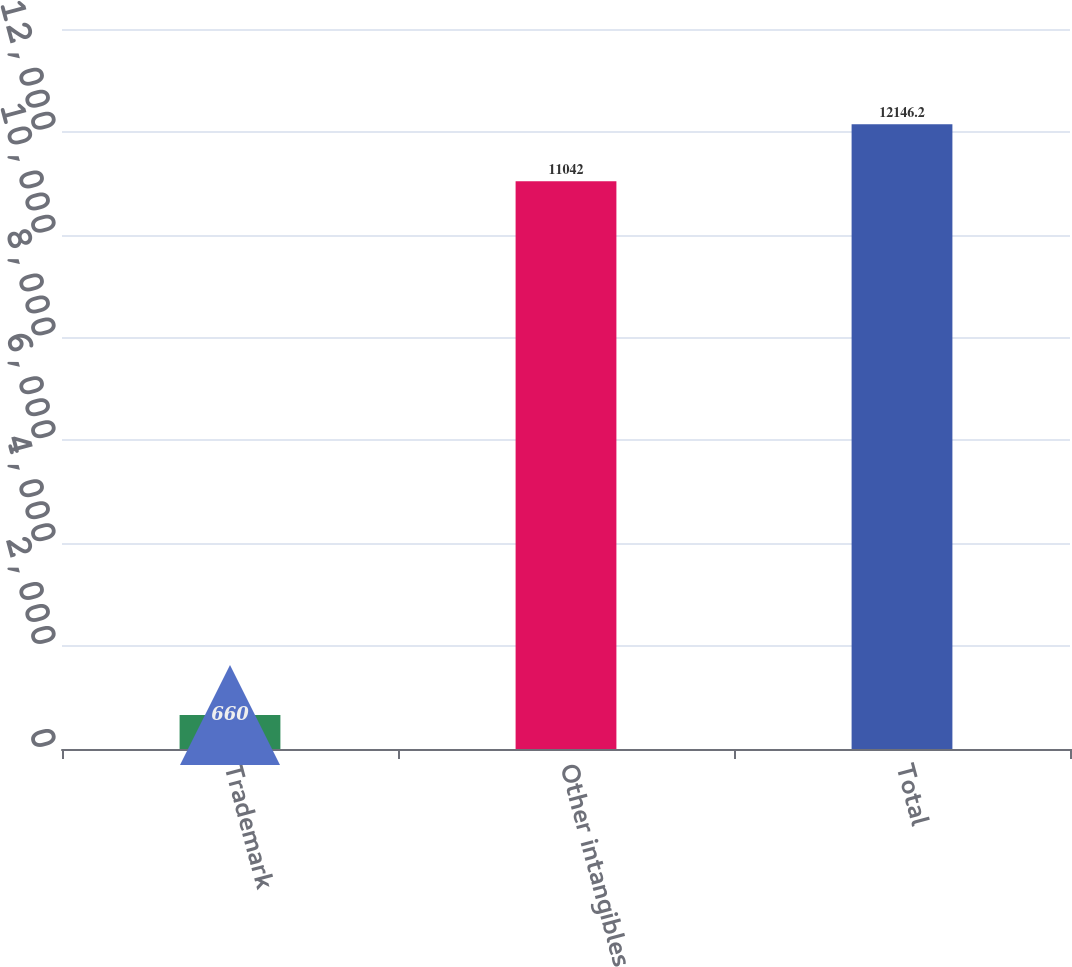Convert chart. <chart><loc_0><loc_0><loc_500><loc_500><bar_chart><fcel>Trademark<fcel>Other intangibles<fcel>Total<nl><fcel>660<fcel>11042<fcel>12146.2<nl></chart> 